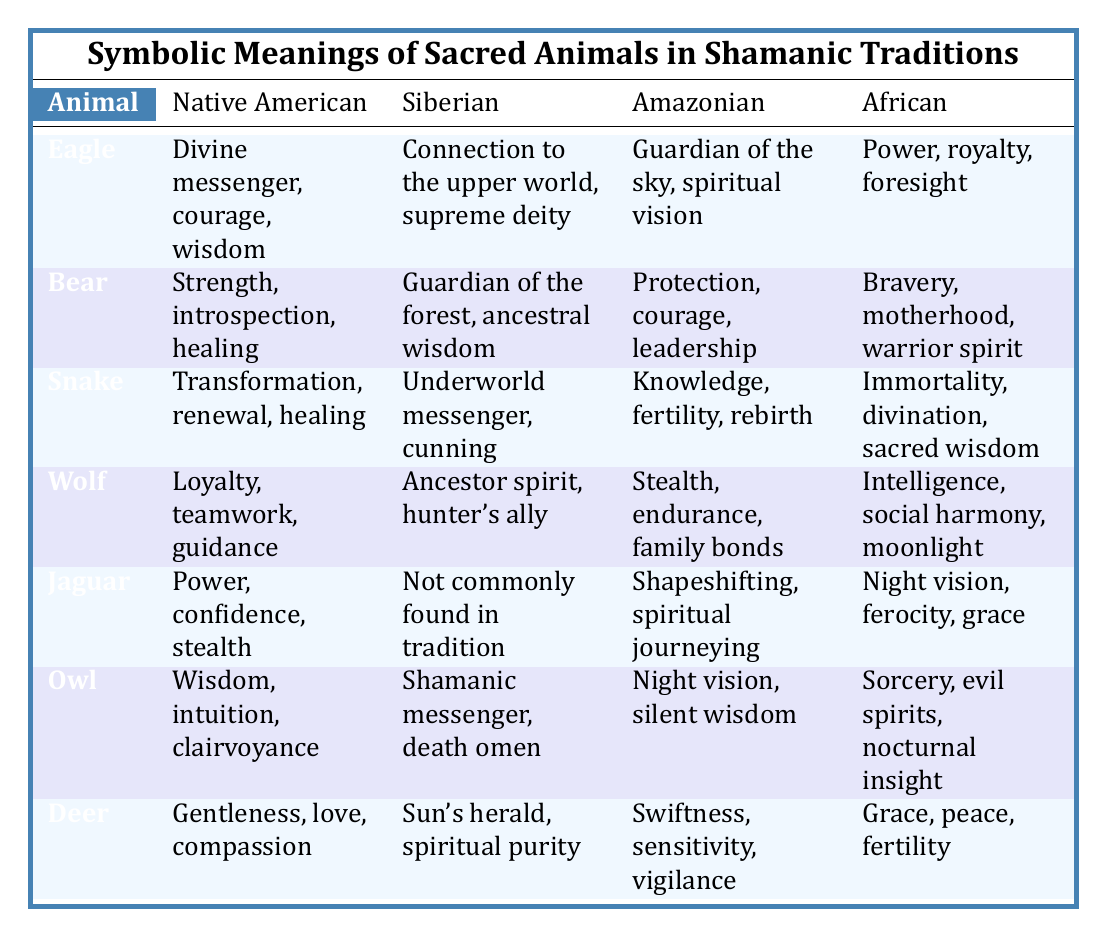What does the Eagle symbolize according to the Amazonian tradition? The table indicates that in Amazonian tradition, the Eagle symbolizes the guardian of the sky and represents spiritual vision. This is found in the "Amazonian" column next to "Eagle."
Answer: Guardian of the sky, spiritual vision Which animal represents transformation in Native American tradition? In the table, the "Snake" is listed under the Native American tradition, where it symbolizes transformation, renewal, and healing. This is directly retrieved from the Native American column for the Snake entry.
Answer: Snake Is the Bear considered a guardian spirit in Siberian tradition? The table states that the Bear is known as the guardian of the forest and ancestral wisdom in Siberian tradition. Therefore, it can be interpreted that Bear is indeed regarded as a guardian spirit in that culture.
Answer: Yes What is the average number of symbolic meanings provided for the animals in the Native American tradition? By counting the unique meanings for each animal listed in the Native American column, the total is 6 (Eagle: 3, Bear: 3, Snake: 3, Wolf: 3, Jaguar: 3, Owl: 3, Deer: 3). Dividing this total by the 7 animals yields an average of 3 meanings per animal (21/7). Since each animal has 3 meanings, the average is 3.
Answer: 3 What symbolic meaning is shared by both the Snake and Owl in African tradition? Referring to the table, the Snake is associated with immortality, divination, and sacred wisdom, while the Owl symbolizes sorcery, evil spirits, and nocturnal insight in African tradition. Since both animals have their unique symbols listed with no overlapping meanings in the African column, there is no shared meaning.
Answer: None 